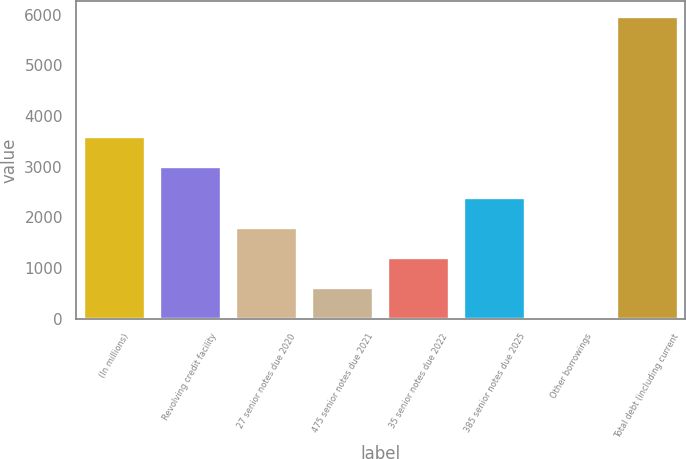<chart> <loc_0><loc_0><loc_500><loc_500><bar_chart><fcel>(In millions)<fcel>Revolving credit facility<fcel>27 senior notes due 2020<fcel>475 senior notes due 2021<fcel>35 senior notes due 2022<fcel>385 senior notes due 2025<fcel>Other borrowings<fcel>Total debt (including current<nl><fcel>3579<fcel>2984<fcel>1794<fcel>604<fcel>1199<fcel>2389<fcel>9<fcel>5959<nl></chart> 